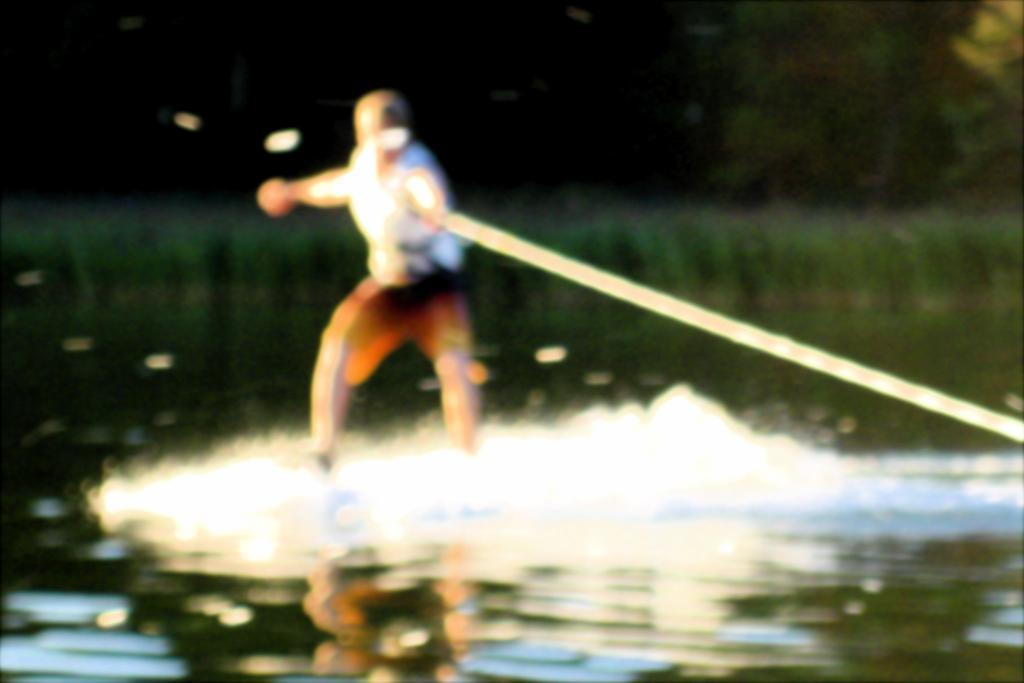What is the main subject of the image? There is a person in the image. What is the person doing in the image? The person is standing on an object on the water. What is the person holding in the image? The person is holding a rope. What can be seen in the background of the image? There are trees in the background of the image. What type of apparel is the person wearing to protect themselves from the powder in the image? There is no powder present in the image, and the person's apparel is not mentioned in the provided facts. 